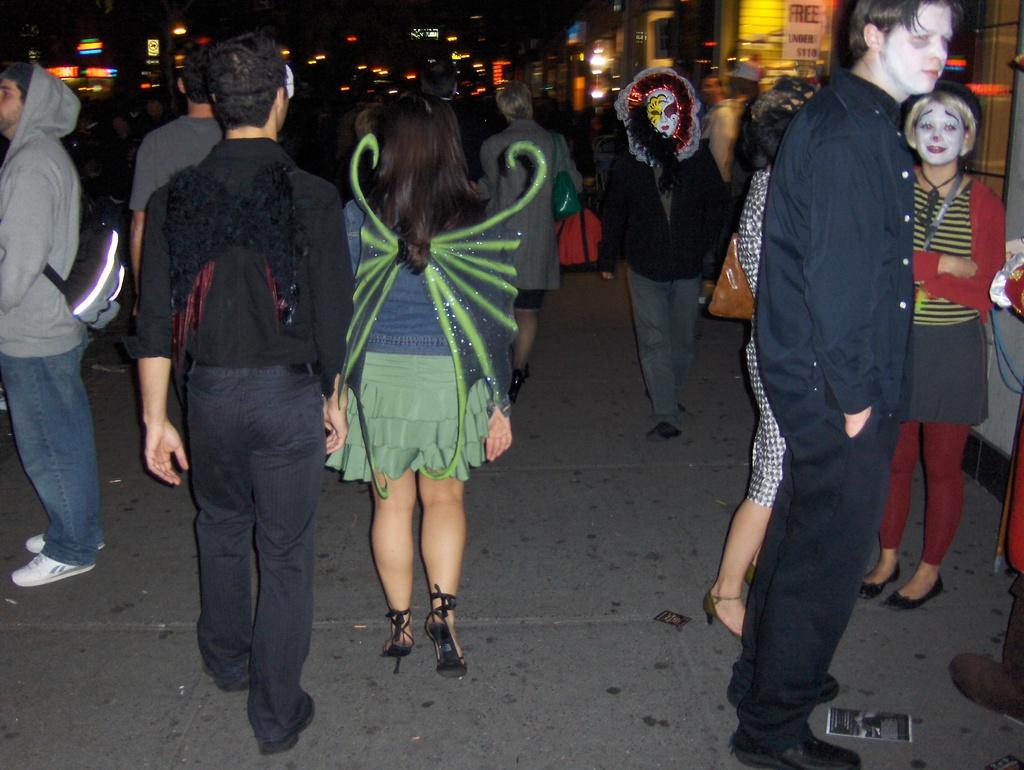What is the main subject in the foreground of the image? There is a crowd in the foreground of the image. Where is the crowd located? The crowd is on the road. What can be seen in the background of the image? There are buildings, boards, and lights in the background of the image. What time of day does the image appear to be taken? The image appears to be taken during the night, as indicated by the dark color. How does the scarecrow affect the acoustics of the crowd in the image? There is no scarecrow present in the image, so it cannot affect the acoustics of the crowd. 